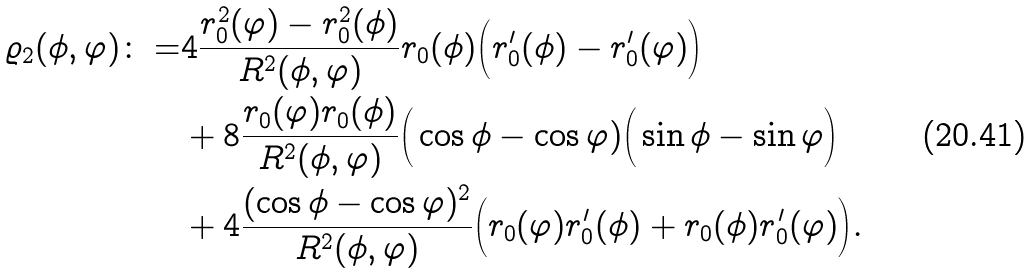Convert formula to latex. <formula><loc_0><loc_0><loc_500><loc_500>\varrho _ { 2 } ( \phi , \varphi ) \colon = & 4 \frac { r _ { 0 } ^ { 2 } ( \varphi ) - r _ { 0 } ^ { 2 } ( \phi ) } { R ^ { 2 } ( \phi , \varphi ) } r _ { 0 } ( \phi ) \Big ( r _ { 0 } ^ { \prime } ( \phi ) - r _ { 0 } ^ { \prime } ( \varphi ) \Big ) \\ & + 8 \frac { r _ { 0 } ( \varphi ) r _ { 0 } ( \phi ) } { R ^ { 2 } ( \phi , \varphi ) } \Big ( \cos \phi - \cos \varphi ) \Big ( \sin \phi - \sin \varphi \Big ) \\ & + 4 \frac { ( \cos \phi - \cos \varphi ) ^ { 2 } } { R ^ { 2 } ( \phi , \varphi ) } \Big ( r _ { 0 } ( \varphi ) r _ { 0 } ^ { \prime } ( \phi ) + r _ { 0 } ( \phi ) r _ { 0 } ^ { \prime } ( \varphi ) \Big ) .</formula> 